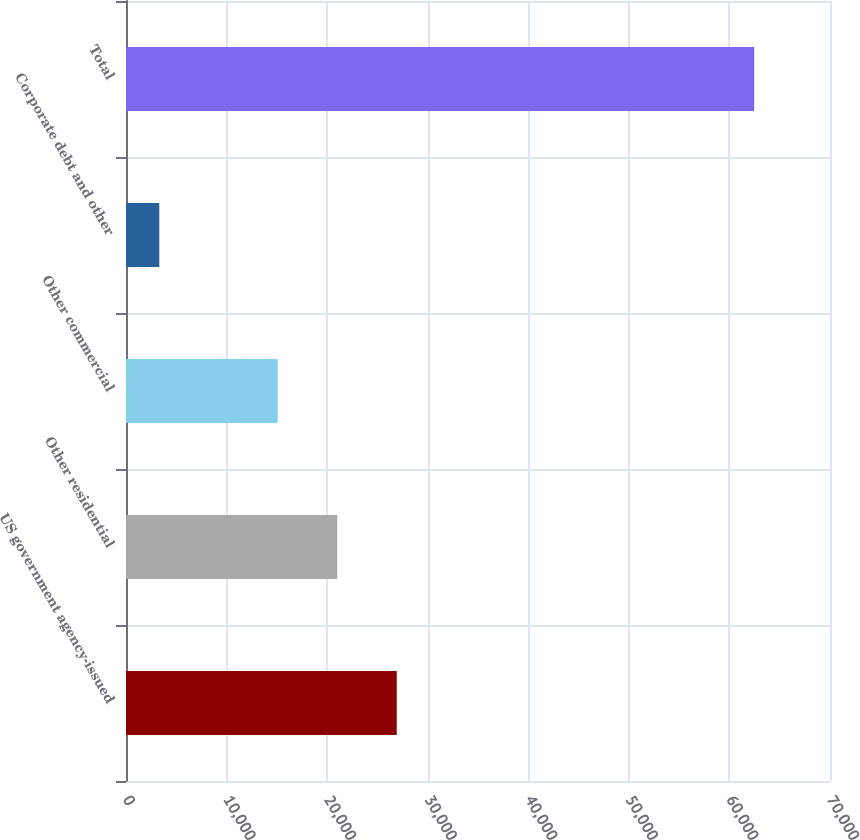Convert chart. <chart><loc_0><loc_0><loc_500><loc_500><bar_chart><fcel>US government agency-issued<fcel>Other residential<fcel>Other commercial<fcel>Corporate debt and other<fcel>Total<nl><fcel>26918.8<fcel>21003.4<fcel>15088<fcel>3311<fcel>62465<nl></chart> 